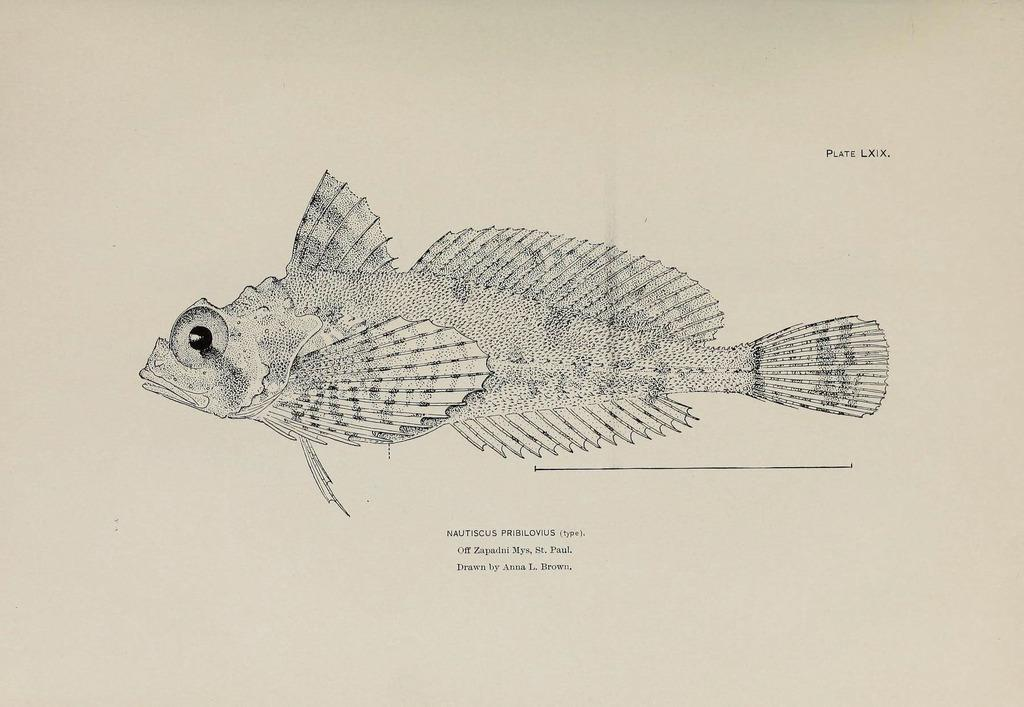What is depicted in the image? There is an art of a fish in the image. What color is the art of the fish? The art of the fish is in black color. What color is the paper on which the art is drawn? The paper is in white color. How many cups are visible in the image? There are no cups visible in the image; it features an art of a fish on a white paper. 